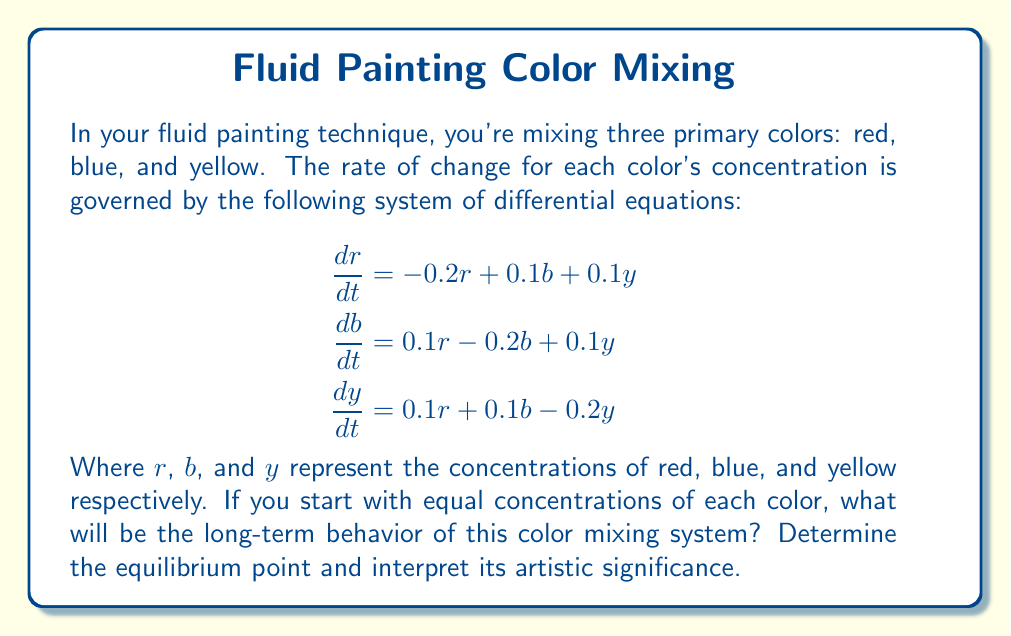Could you help me with this problem? Let's approach this step-by-step:

1) To find the equilibrium point, we set all derivatives to zero:

   $$\begin{aligned}
   0 &= -0.2r + 0.1b + 0.1y \\
   0 &= 0.1r - 0.2b + 0.1y \\
   0 &= 0.1r + 0.1b - 0.2y
   \end{aligned}$$

2) Adding these equations:

   $0 = 0r + 0b + 0y$

   This is always true, suggesting that the total concentration remains constant.

3) Given equal initial concentrations, let's say $r + b + y = 1$. Due to symmetry, at equilibrium:

   $r = b = y = \frac{1}{3}$

4) We can verify this is indeed the solution:

   $$\begin{aligned}
   -0.2(\frac{1}{3}) + 0.1(\frac{1}{3}) + 0.1(\frac{1}{3}) &= 0 \\
   0.1(\frac{1}{3}) - 0.2(\frac{1}{3}) + 0.1(\frac{1}{3}) &= 0 \\
   0.1(\frac{1}{3}) + 0.1(\frac{1}{3}) - 0.2(\frac{1}{3}) &= 0
   \end{aligned}$$

5) Artistic interpretation: Over time, regardless of the initial mix, the colors will blend to form a perfect gray (equal parts of each primary color).

6) To confirm stability, we could analyze the eigenvalues of the Jacobian matrix, but given the symmetry and conservation of total concentration, this equilibrium point is indeed stable.
Answer: Equilibrium: $r = b = y = \frac{1}{3}$. Artistic significance: Colors blend to gray. 